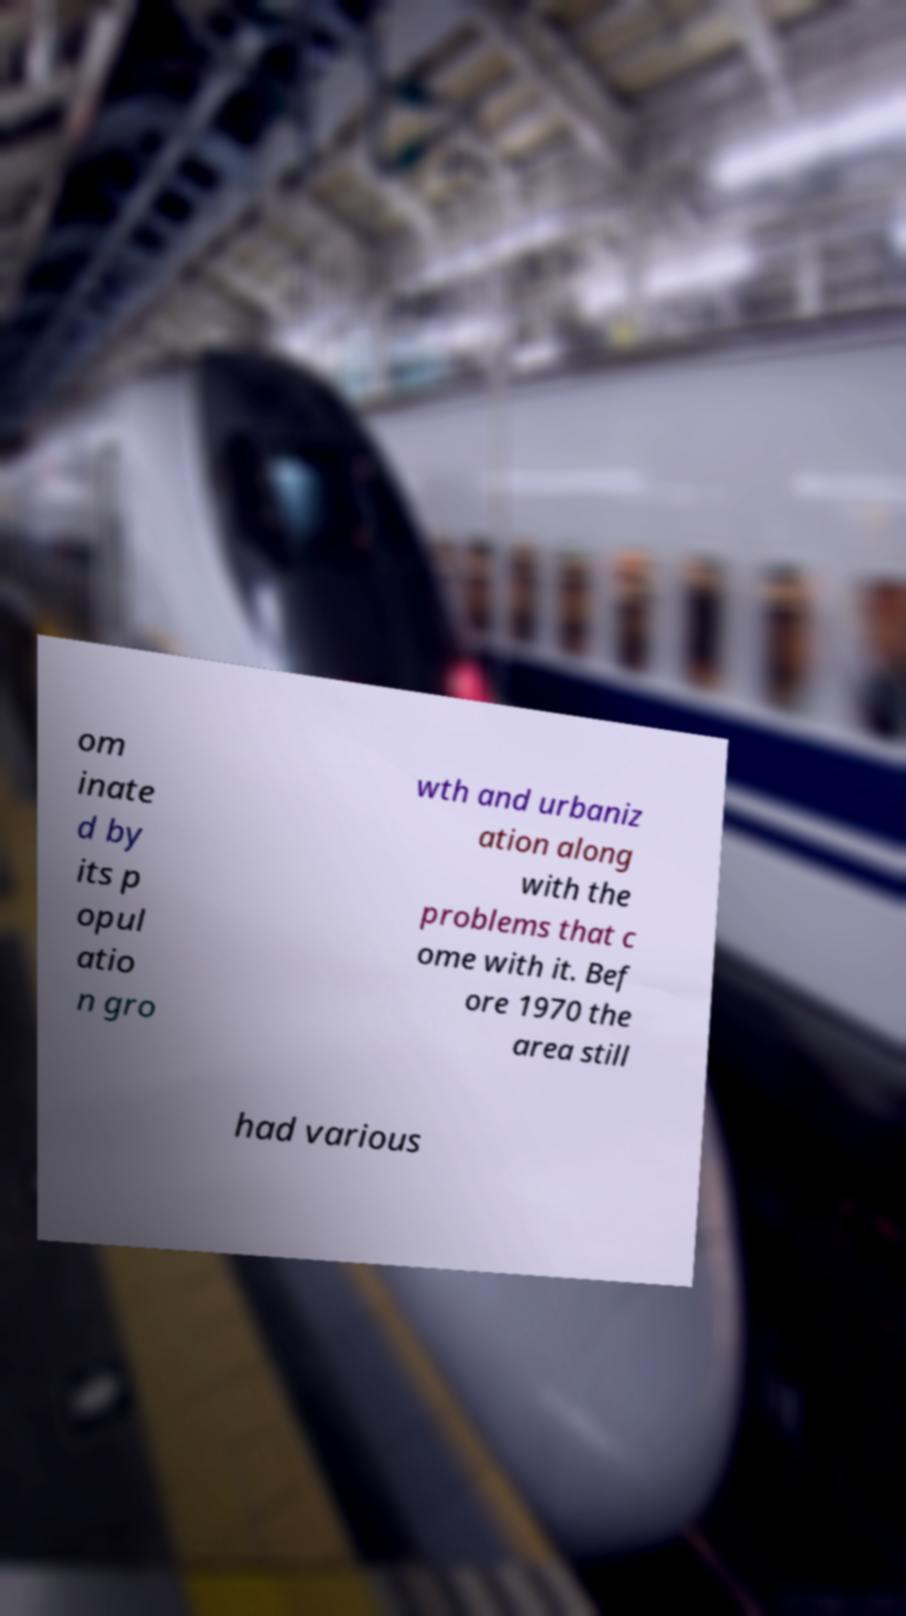I need the written content from this picture converted into text. Can you do that? om inate d by its p opul atio n gro wth and urbaniz ation along with the problems that c ome with it. Bef ore 1970 the area still had various 